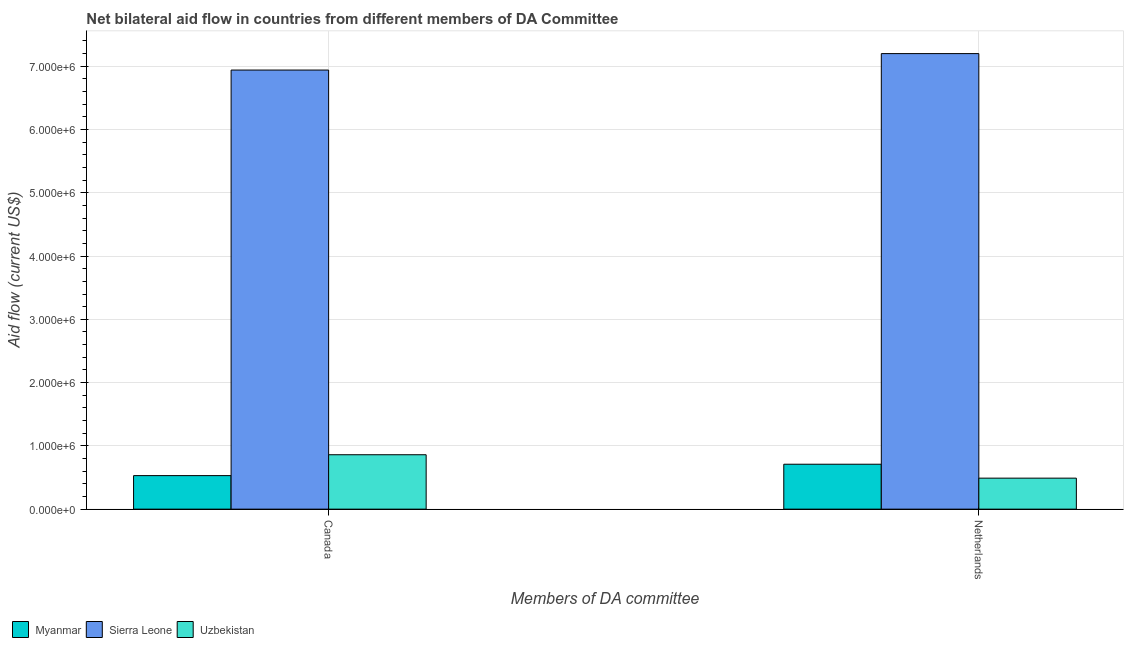How many different coloured bars are there?
Offer a terse response. 3. How many groups of bars are there?
Offer a very short reply. 2. How many bars are there on the 1st tick from the right?
Provide a succinct answer. 3. What is the amount of aid given by canada in Uzbekistan?
Provide a succinct answer. 8.60e+05. Across all countries, what is the maximum amount of aid given by netherlands?
Offer a terse response. 7.20e+06. Across all countries, what is the minimum amount of aid given by canada?
Your response must be concise. 5.30e+05. In which country was the amount of aid given by netherlands maximum?
Provide a succinct answer. Sierra Leone. In which country was the amount of aid given by canada minimum?
Keep it short and to the point. Myanmar. What is the total amount of aid given by netherlands in the graph?
Your response must be concise. 8.40e+06. What is the difference between the amount of aid given by netherlands in Myanmar and that in Uzbekistan?
Your response must be concise. 2.20e+05. What is the difference between the amount of aid given by canada in Sierra Leone and the amount of aid given by netherlands in Uzbekistan?
Your answer should be very brief. 6.45e+06. What is the average amount of aid given by canada per country?
Provide a succinct answer. 2.78e+06. What is the difference between the amount of aid given by netherlands and amount of aid given by canada in Sierra Leone?
Your answer should be compact. 2.60e+05. What is the ratio of the amount of aid given by canada in Uzbekistan to that in Myanmar?
Ensure brevity in your answer.  1.62. In how many countries, is the amount of aid given by canada greater than the average amount of aid given by canada taken over all countries?
Your response must be concise. 1. What does the 2nd bar from the left in Canada represents?
Keep it short and to the point. Sierra Leone. What does the 2nd bar from the right in Canada represents?
Offer a terse response. Sierra Leone. How many bars are there?
Provide a succinct answer. 6. Are all the bars in the graph horizontal?
Offer a terse response. No. How many countries are there in the graph?
Provide a succinct answer. 3. Are the values on the major ticks of Y-axis written in scientific E-notation?
Provide a succinct answer. Yes. Does the graph contain grids?
Ensure brevity in your answer.  Yes. Where does the legend appear in the graph?
Ensure brevity in your answer.  Bottom left. How many legend labels are there?
Your answer should be very brief. 3. How are the legend labels stacked?
Make the answer very short. Horizontal. What is the title of the graph?
Offer a very short reply. Net bilateral aid flow in countries from different members of DA Committee. What is the label or title of the X-axis?
Provide a succinct answer. Members of DA committee. What is the label or title of the Y-axis?
Keep it short and to the point. Aid flow (current US$). What is the Aid flow (current US$) in Myanmar in Canada?
Provide a short and direct response. 5.30e+05. What is the Aid flow (current US$) of Sierra Leone in Canada?
Your answer should be very brief. 6.94e+06. What is the Aid flow (current US$) in Uzbekistan in Canada?
Your answer should be very brief. 8.60e+05. What is the Aid flow (current US$) in Myanmar in Netherlands?
Provide a short and direct response. 7.10e+05. What is the Aid flow (current US$) of Sierra Leone in Netherlands?
Provide a succinct answer. 7.20e+06. What is the Aid flow (current US$) of Uzbekistan in Netherlands?
Ensure brevity in your answer.  4.90e+05. Across all Members of DA committee, what is the maximum Aid flow (current US$) in Myanmar?
Offer a very short reply. 7.10e+05. Across all Members of DA committee, what is the maximum Aid flow (current US$) of Sierra Leone?
Your answer should be compact. 7.20e+06. Across all Members of DA committee, what is the maximum Aid flow (current US$) of Uzbekistan?
Provide a succinct answer. 8.60e+05. Across all Members of DA committee, what is the minimum Aid flow (current US$) in Myanmar?
Offer a terse response. 5.30e+05. Across all Members of DA committee, what is the minimum Aid flow (current US$) of Sierra Leone?
Make the answer very short. 6.94e+06. What is the total Aid flow (current US$) in Myanmar in the graph?
Ensure brevity in your answer.  1.24e+06. What is the total Aid flow (current US$) of Sierra Leone in the graph?
Your response must be concise. 1.41e+07. What is the total Aid flow (current US$) in Uzbekistan in the graph?
Provide a short and direct response. 1.35e+06. What is the difference between the Aid flow (current US$) in Sierra Leone in Canada and that in Netherlands?
Give a very brief answer. -2.60e+05. What is the difference between the Aid flow (current US$) of Uzbekistan in Canada and that in Netherlands?
Ensure brevity in your answer.  3.70e+05. What is the difference between the Aid flow (current US$) of Myanmar in Canada and the Aid flow (current US$) of Sierra Leone in Netherlands?
Offer a terse response. -6.67e+06. What is the difference between the Aid flow (current US$) in Myanmar in Canada and the Aid flow (current US$) in Uzbekistan in Netherlands?
Give a very brief answer. 4.00e+04. What is the difference between the Aid flow (current US$) in Sierra Leone in Canada and the Aid flow (current US$) in Uzbekistan in Netherlands?
Your answer should be compact. 6.45e+06. What is the average Aid flow (current US$) of Myanmar per Members of DA committee?
Your answer should be compact. 6.20e+05. What is the average Aid flow (current US$) of Sierra Leone per Members of DA committee?
Provide a short and direct response. 7.07e+06. What is the average Aid flow (current US$) of Uzbekistan per Members of DA committee?
Ensure brevity in your answer.  6.75e+05. What is the difference between the Aid flow (current US$) of Myanmar and Aid flow (current US$) of Sierra Leone in Canada?
Your answer should be very brief. -6.41e+06. What is the difference between the Aid flow (current US$) of Myanmar and Aid flow (current US$) of Uzbekistan in Canada?
Make the answer very short. -3.30e+05. What is the difference between the Aid flow (current US$) in Sierra Leone and Aid flow (current US$) in Uzbekistan in Canada?
Provide a succinct answer. 6.08e+06. What is the difference between the Aid flow (current US$) of Myanmar and Aid flow (current US$) of Sierra Leone in Netherlands?
Provide a short and direct response. -6.49e+06. What is the difference between the Aid flow (current US$) in Sierra Leone and Aid flow (current US$) in Uzbekistan in Netherlands?
Your response must be concise. 6.71e+06. What is the ratio of the Aid flow (current US$) in Myanmar in Canada to that in Netherlands?
Your response must be concise. 0.75. What is the ratio of the Aid flow (current US$) in Sierra Leone in Canada to that in Netherlands?
Provide a succinct answer. 0.96. What is the ratio of the Aid flow (current US$) in Uzbekistan in Canada to that in Netherlands?
Offer a terse response. 1.76. What is the difference between the highest and the second highest Aid flow (current US$) in Uzbekistan?
Provide a short and direct response. 3.70e+05. What is the difference between the highest and the lowest Aid flow (current US$) in Myanmar?
Make the answer very short. 1.80e+05. What is the difference between the highest and the lowest Aid flow (current US$) of Uzbekistan?
Your response must be concise. 3.70e+05. 